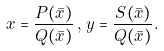<formula> <loc_0><loc_0><loc_500><loc_500>x = \frac { P ( \bar { x } ) } { Q ( \bar { x } ) } \, , \, y = \frac { S ( \bar { x } ) } { Q ( \bar { x } ) } .</formula> 